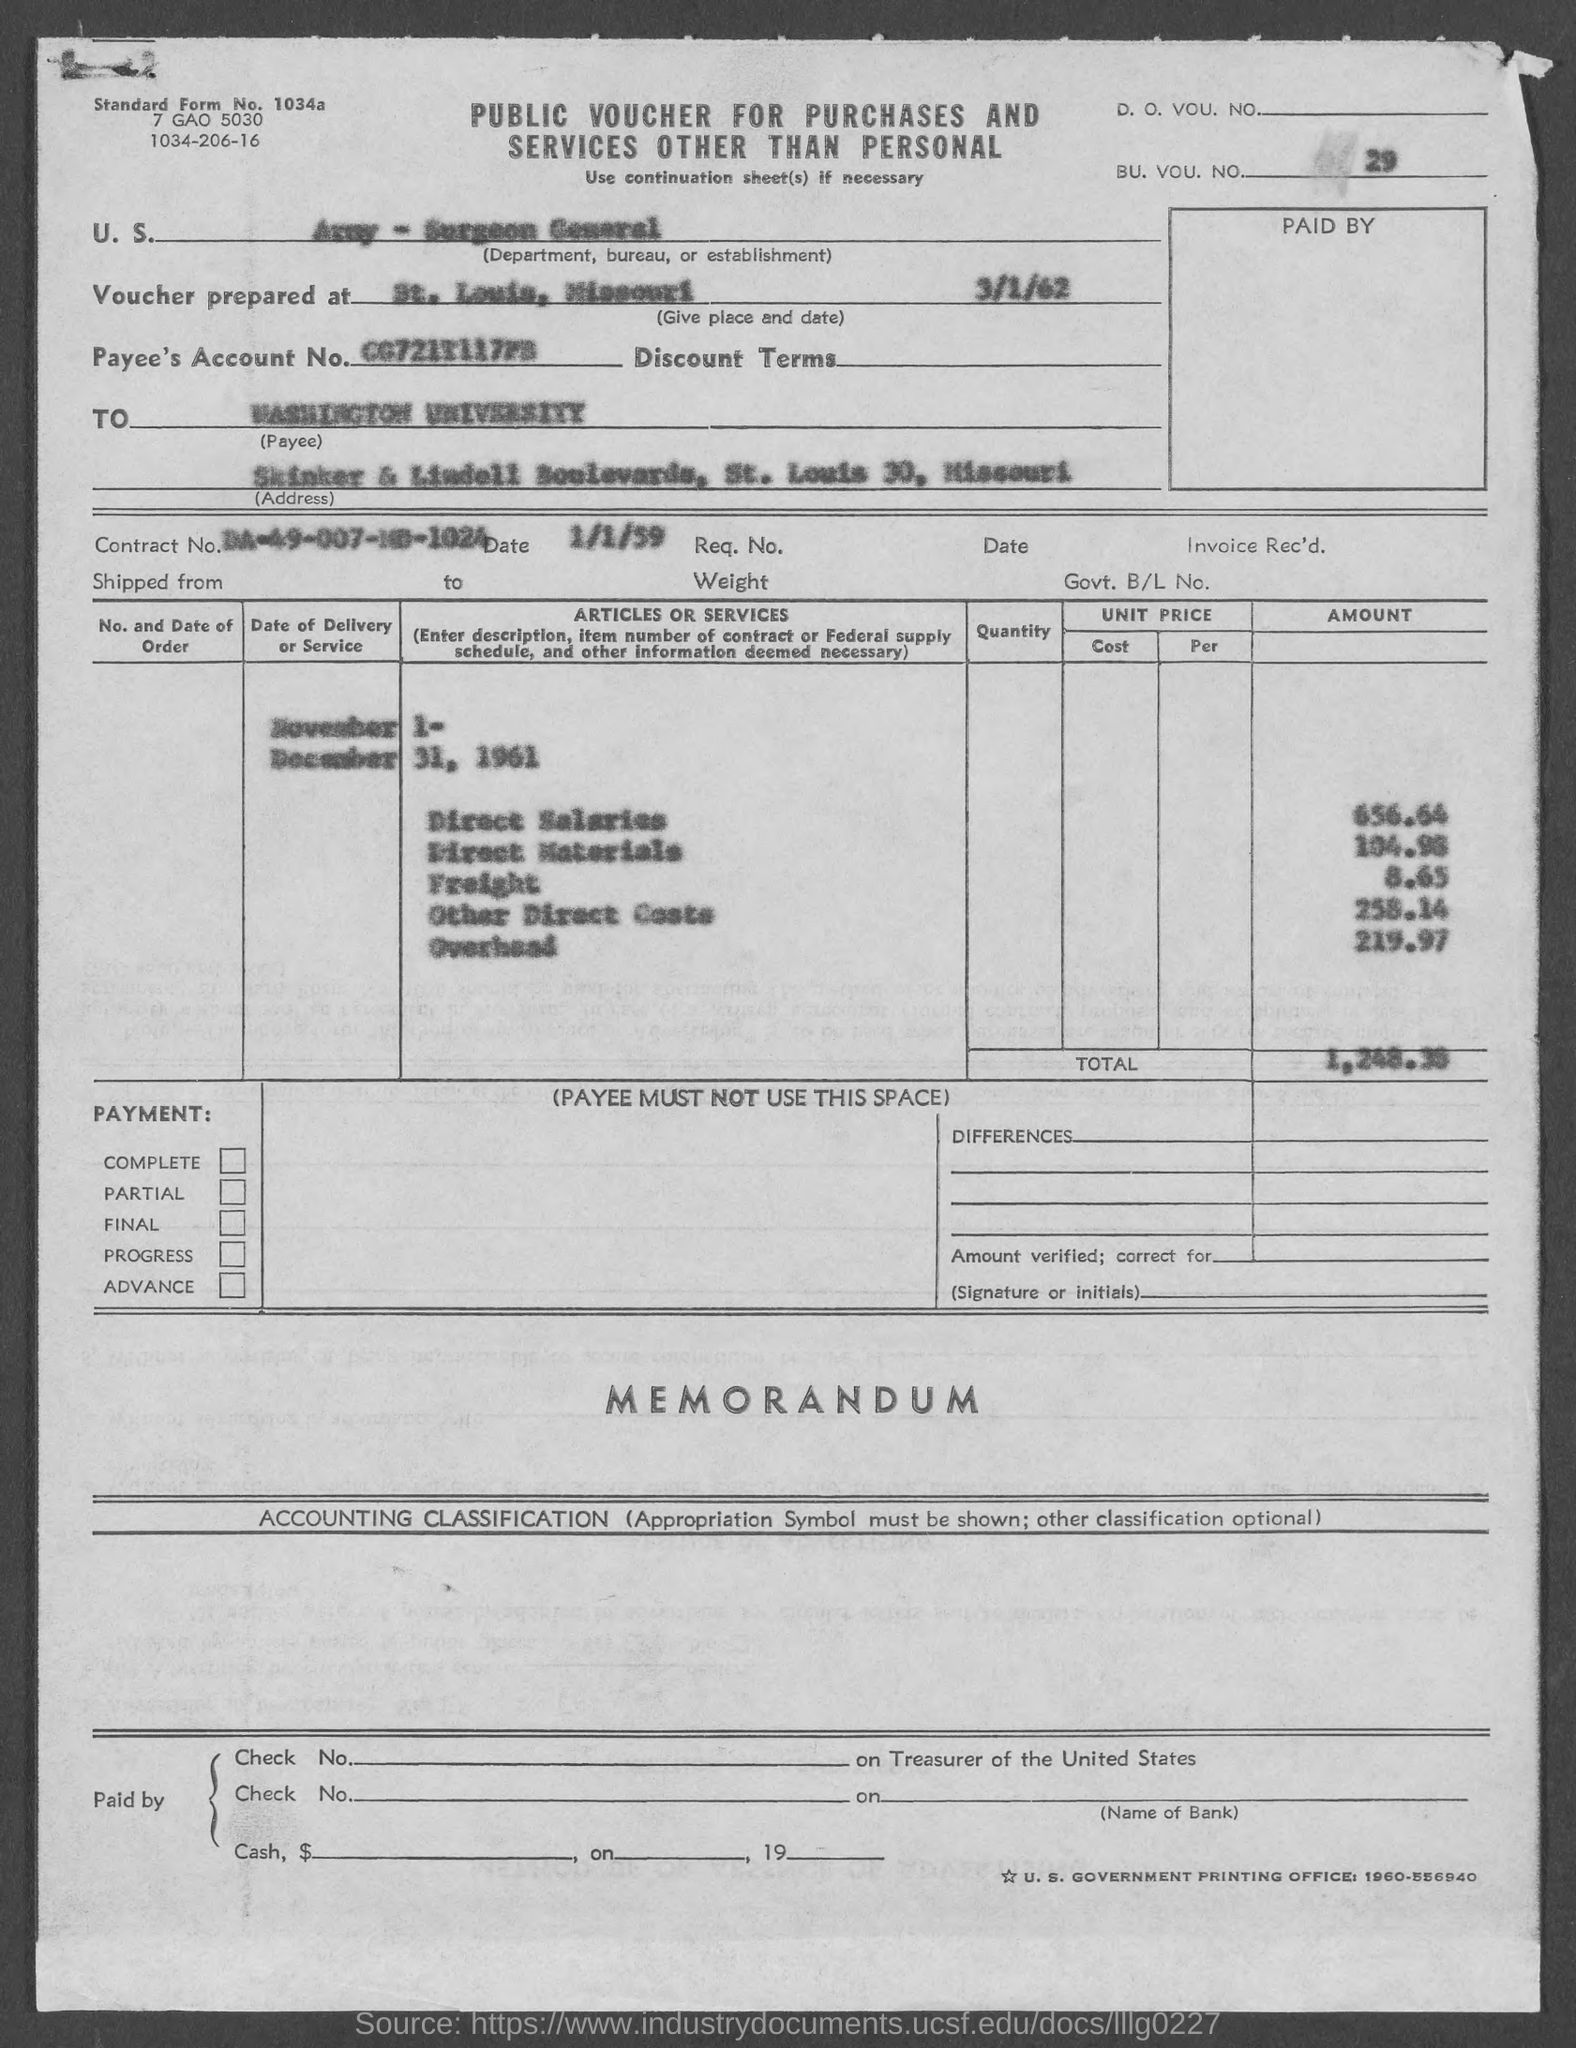Give some essential details in this illustration. The date associated with Contract No. is January 1, 1959. What is the standard form number? What is the BU. VOU. number?" is a question that is asking for information about a specific number. The street address of Washington University is located at Skinker & Lindell Boulevards. The contract number is DA-49-007-MD-1024. 